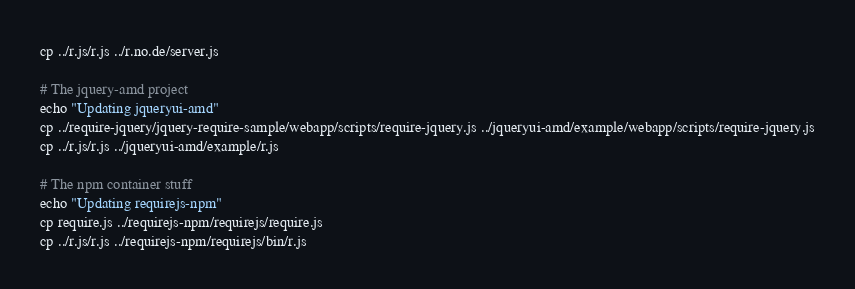Convert code to text. <code><loc_0><loc_0><loc_500><loc_500><_Bash_>cp ../r.js/r.js ../r.no.de/server.js

# The jquery-amd project
echo "Updating jqueryui-amd"
cp ../require-jquery/jquery-require-sample/webapp/scripts/require-jquery.js ../jqueryui-amd/example/webapp/scripts/require-jquery.js
cp ../r.js/r.js ../jqueryui-amd/example/r.js

# The npm container stuff
echo "Updating requirejs-npm"
cp require.js ../requirejs-npm/requirejs/require.js
cp ../r.js/r.js ../requirejs-npm/requirejs/bin/r.js
</code> 